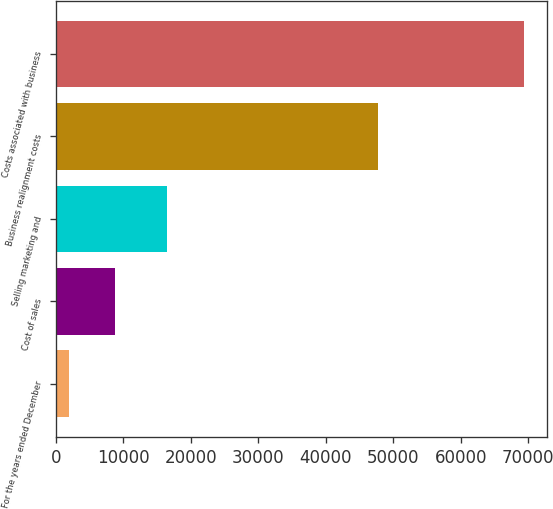Convert chart. <chart><loc_0><loc_0><loc_500><loc_500><bar_chart><fcel>For the years ended December<fcel>Cost of sales<fcel>Selling marketing and<fcel>Business realignment costs<fcel>Costs associated with business<nl><fcel>2017<fcel>8751.2<fcel>16449<fcel>47763<fcel>69359<nl></chart> 